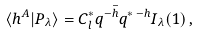Convert formula to latex. <formula><loc_0><loc_0><loc_500><loc_500>\langle h ^ { A } | P _ { \lambda } \rangle = C _ { l } ^ { * } q ^ { - \bar { h } } q ^ { * \, - h } I _ { \lambda } ( 1 ) \, ,</formula> 